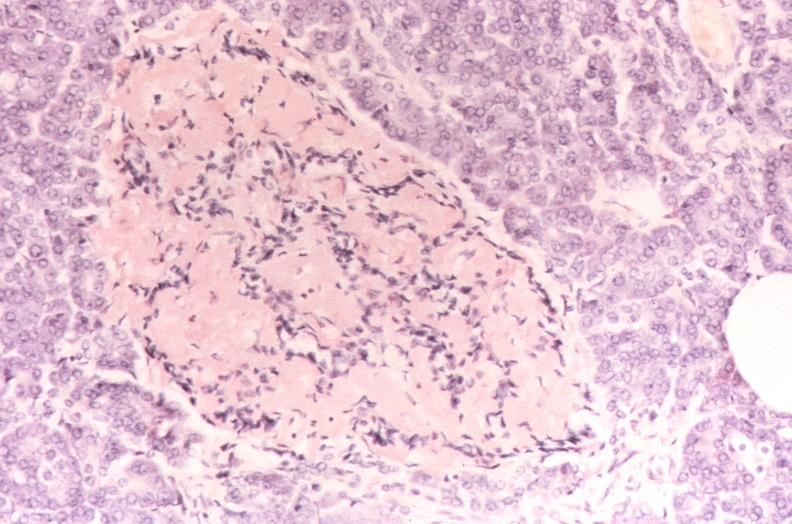does pancreatic islet, amyloidosis diabetes mellitus, congo red stain?
Answer the question using a single word or phrase. Yes 